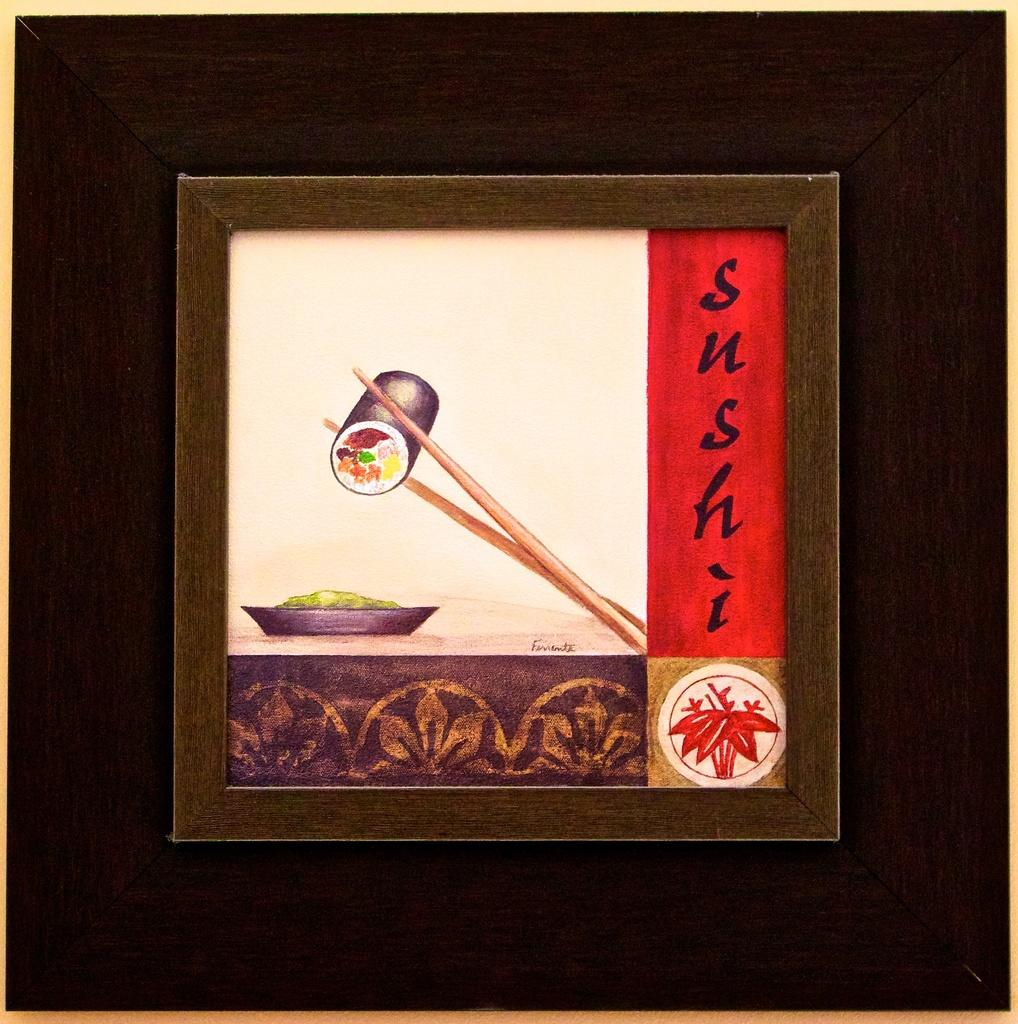<image>
Describe the image concisely. A drawing of chopsticks holding a sushi roll with Sushi written next to the drawing. 